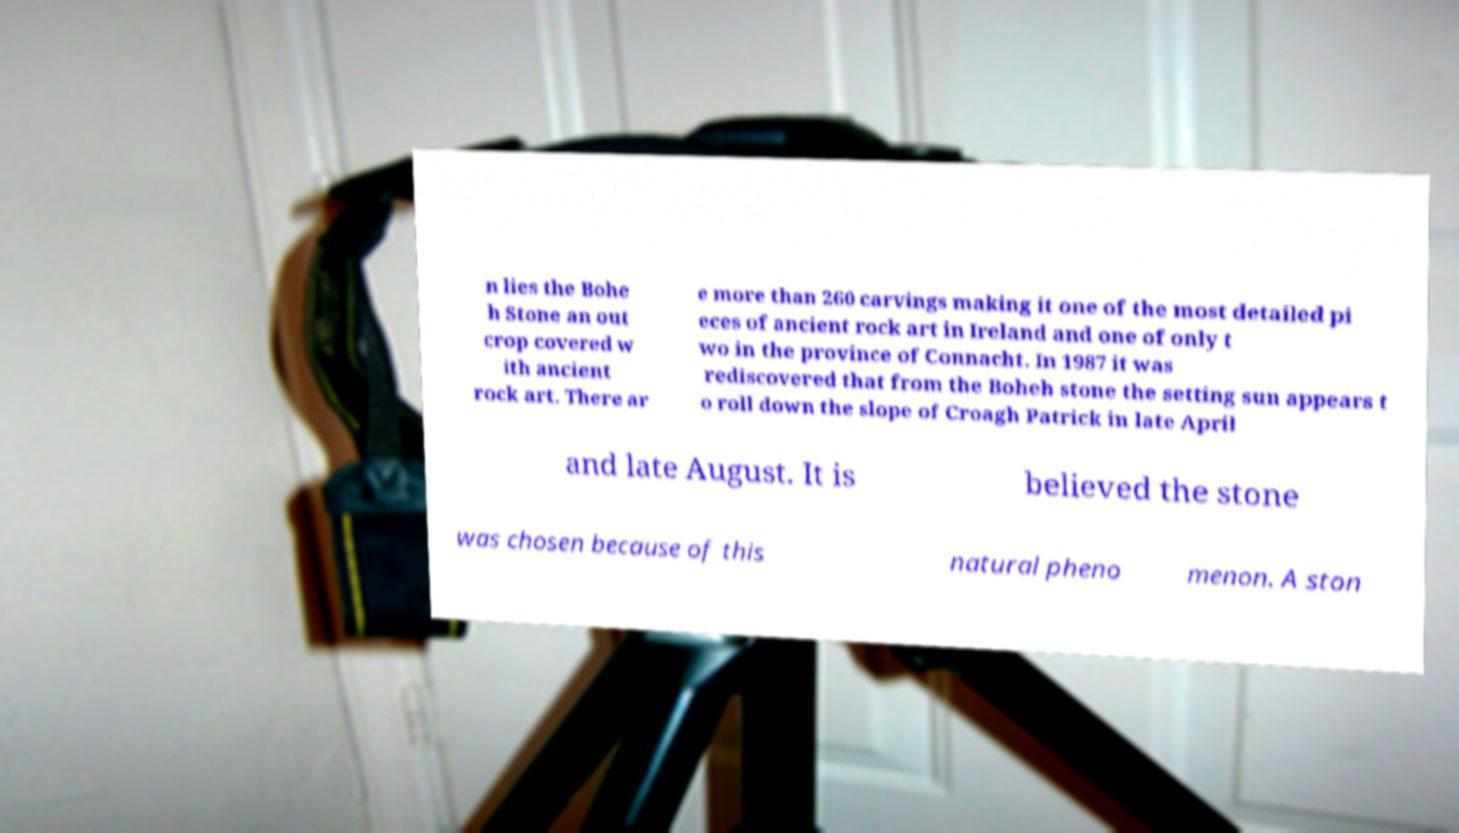Can you accurately transcribe the text from the provided image for me? n lies the Bohe h Stone an out crop covered w ith ancient rock art. There ar e more than 260 carvings making it one of the most detailed pi eces of ancient rock art in Ireland and one of only t wo in the province of Connacht. In 1987 it was rediscovered that from the Boheh stone the setting sun appears t o roll down the slope of Croagh Patrick in late April and late August. It is believed the stone was chosen because of this natural pheno menon. A ston 